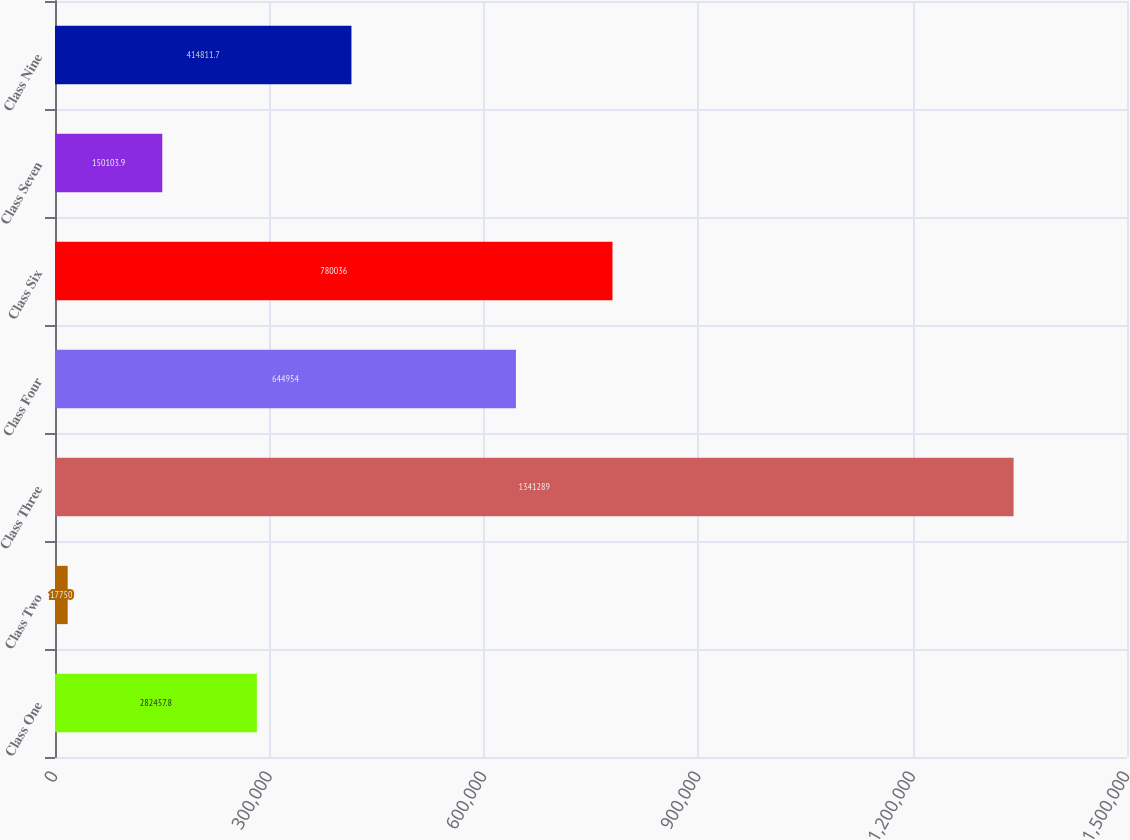Convert chart. <chart><loc_0><loc_0><loc_500><loc_500><bar_chart><fcel>Class One<fcel>Class Two<fcel>Class Three<fcel>Class Four<fcel>Class Six<fcel>Class Seven<fcel>Class Nine<nl><fcel>282458<fcel>17750<fcel>1.34129e+06<fcel>644954<fcel>780036<fcel>150104<fcel>414812<nl></chart> 